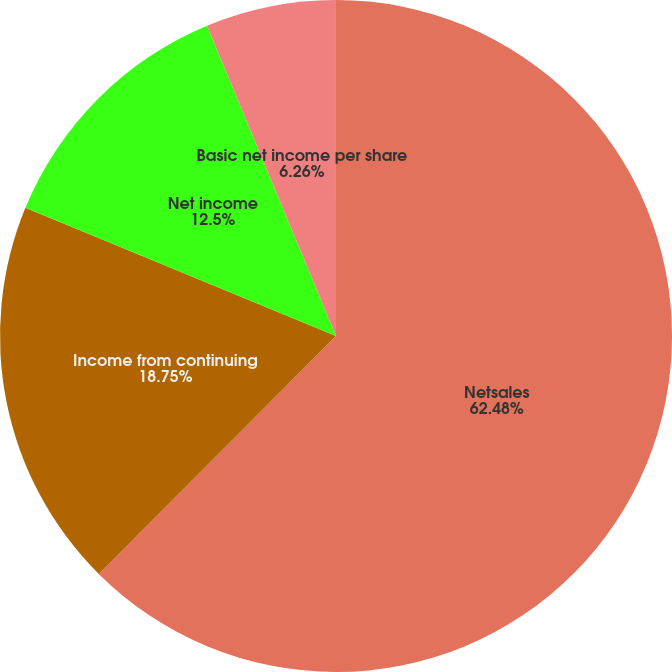<chart> <loc_0><loc_0><loc_500><loc_500><pie_chart><fcel>Netsales<fcel>Income from continuing<fcel>Net income<fcel>Basic net income per share<fcel>Dilutednet income per share<nl><fcel>62.47%<fcel>18.75%<fcel>12.5%<fcel>6.26%<fcel>0.01%<nl></chart> 